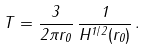<formula> <loc_0><loc_0><loc_500><loc_500>T = \frac { 3 } { 2 \pi r _ { 0 } } \, \frac { 1 } { H ^ { 1 / 2 } ( r _ { 0 } ) } \, .</formula> 